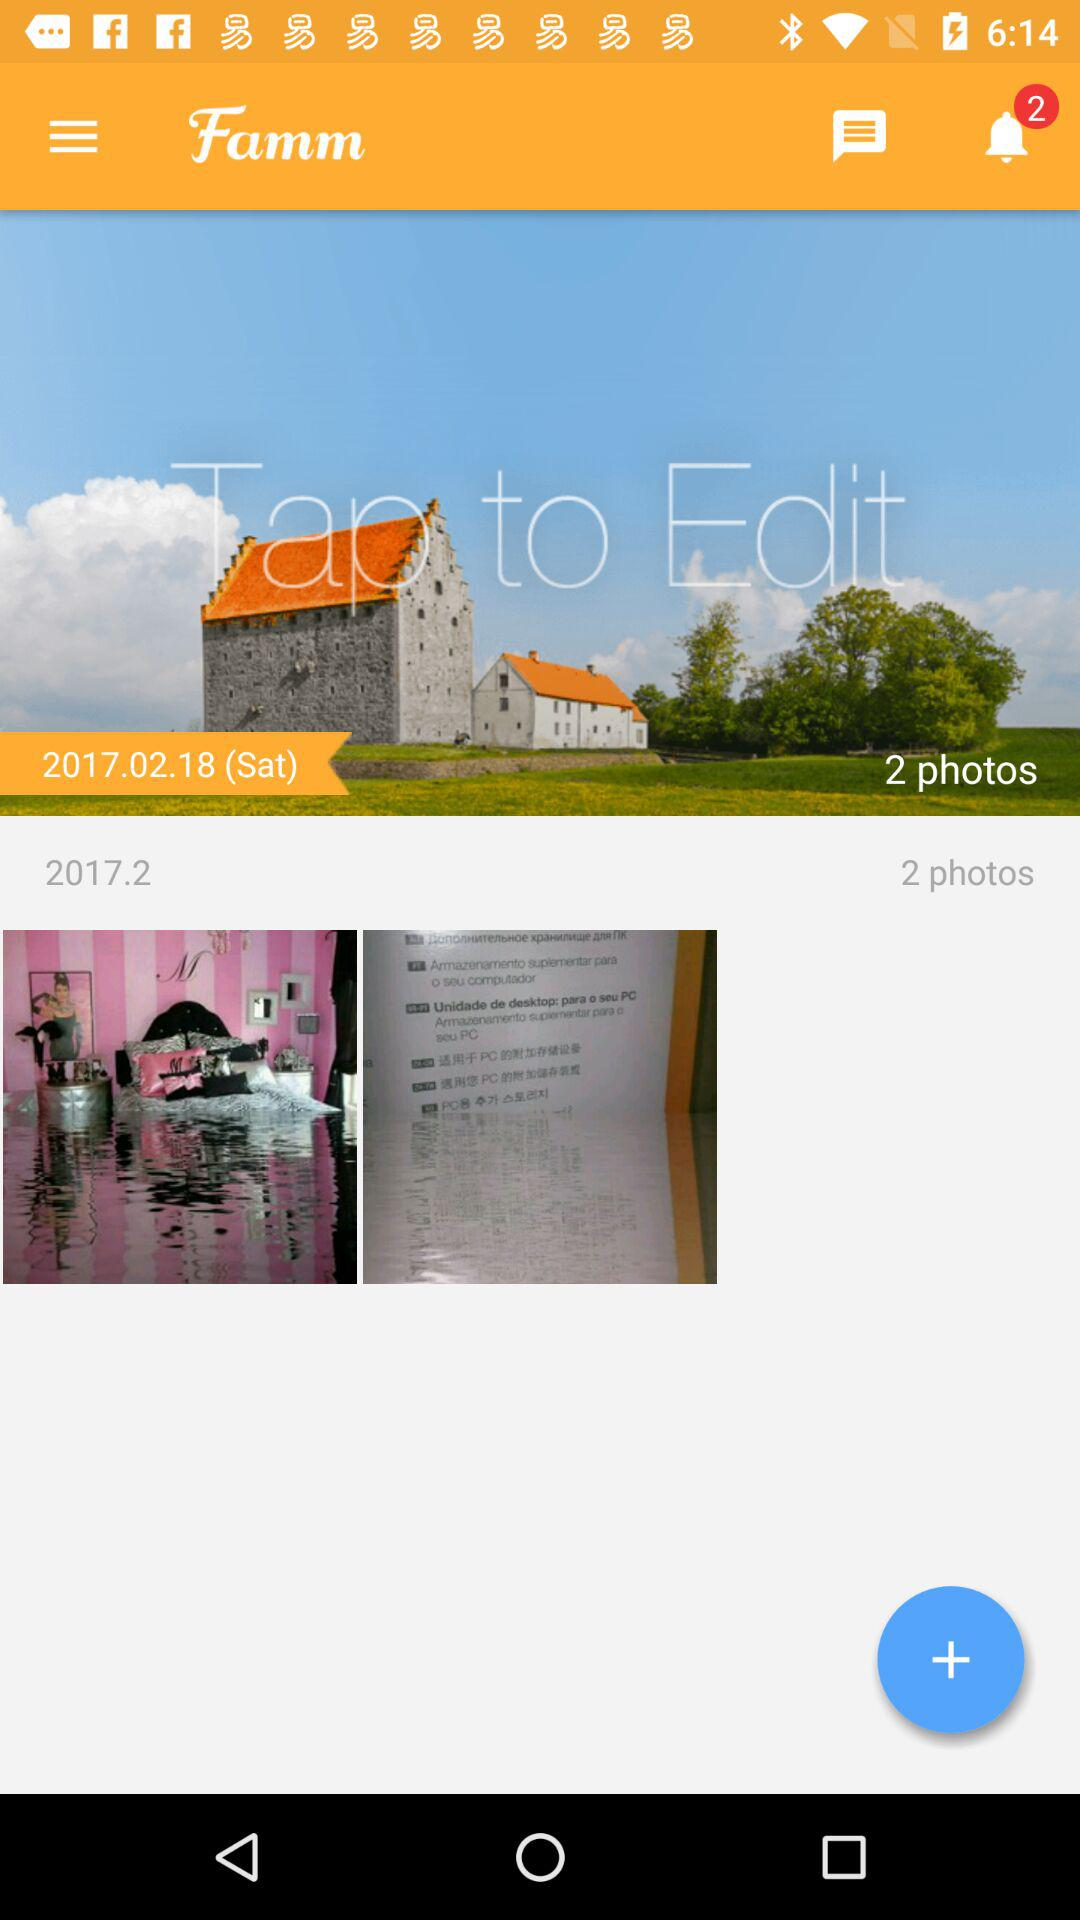What date is mentioned? The mentioned date is 2017.02.18 (Sat). 